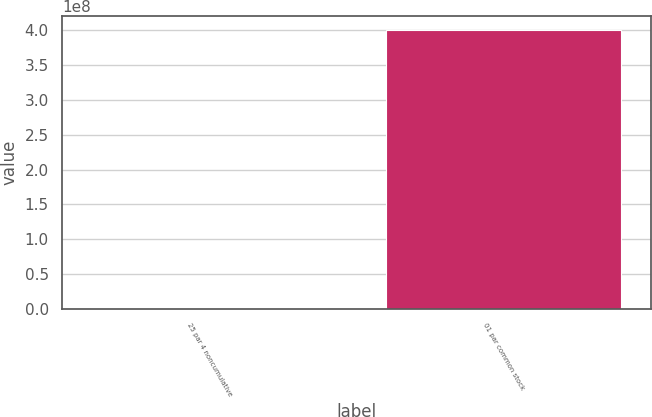<chart> <loc_0><loc_0><loc_500><loc_500><bar_chart><fcel>25 par 4 noncumulative<fcel>01 par common stock<nl><fcel>840000<fcel>4e+08<nl></chart> 